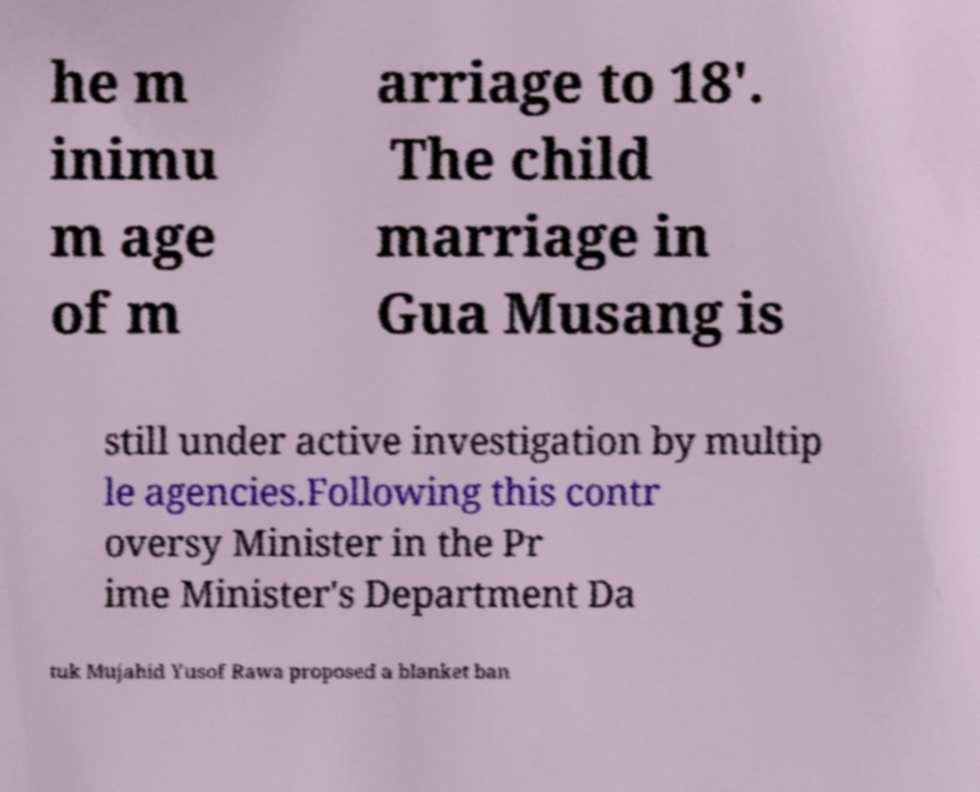Could you extract and type out the text from this image? he m inimu m age of m arriage to 18'. The child marriage in Gua Musang is still under active investigation by multip le agencies.Following this contr oversy Minister in the Pr ime Minister's Department Da tuk Mujahid Yusof Rawa proposed a blanket ban 